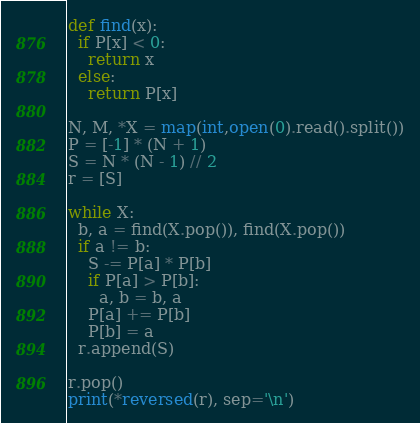Convert code to text. <code><loc_0><loc_0><loc_500><loc_500><_Python_>def find(x):
  if P[x] < 0:
    return x
  else:
    return P[x]

N, M, *X = map(int,open(0).read().split())
P = [-1] * (N + 1)
S = N * (N - 1) // 2
r = [S]

while X:
  b, a = find(X.pop()), find(X.pop())
  if a != b:
    S -= P[a] * P[b]
    if P[a] > P[b]:
      a, b = b, a
    P[a] += P[b]
    P[b] = a
  r.append(S)

r.pop()
print(*reversed(r), sep='\n')</code> 